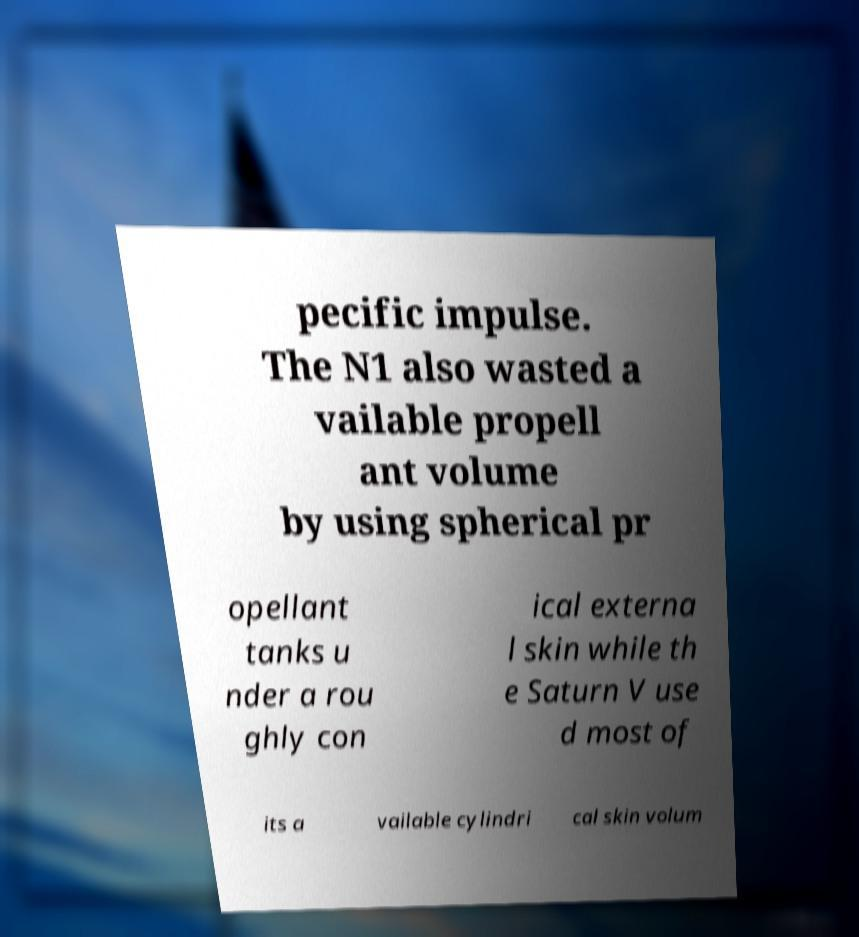There's text embedded in this image that I need extracted. Can you transcribe it verbatim? pecific impulse. The N1 also wasted a vailable propell ant volume by using spherical pr opellant tanks u nder a rou ghly con ical externa l skin while th e Saturn V use d most of its a vailable cylindri cal skin volum 